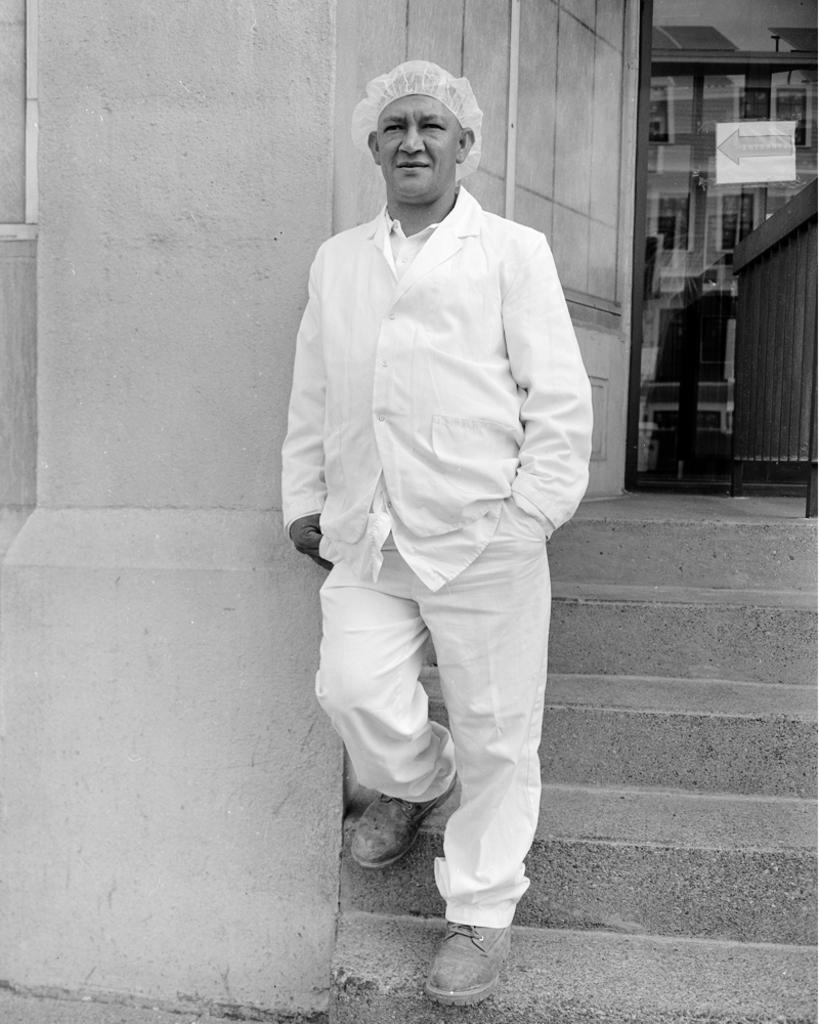Who is present in the image? There is a man in the image. What is the man doing in the image? The man is walking in the image. What expression does the man have in the image? The man is smiling in the image. What can be seen in the background of the image? There is a wall in the background of the image. How many bits of hope can be seen in the image? There is no reference to "bits of hope" in the image, so it is not possible to answer that question. 